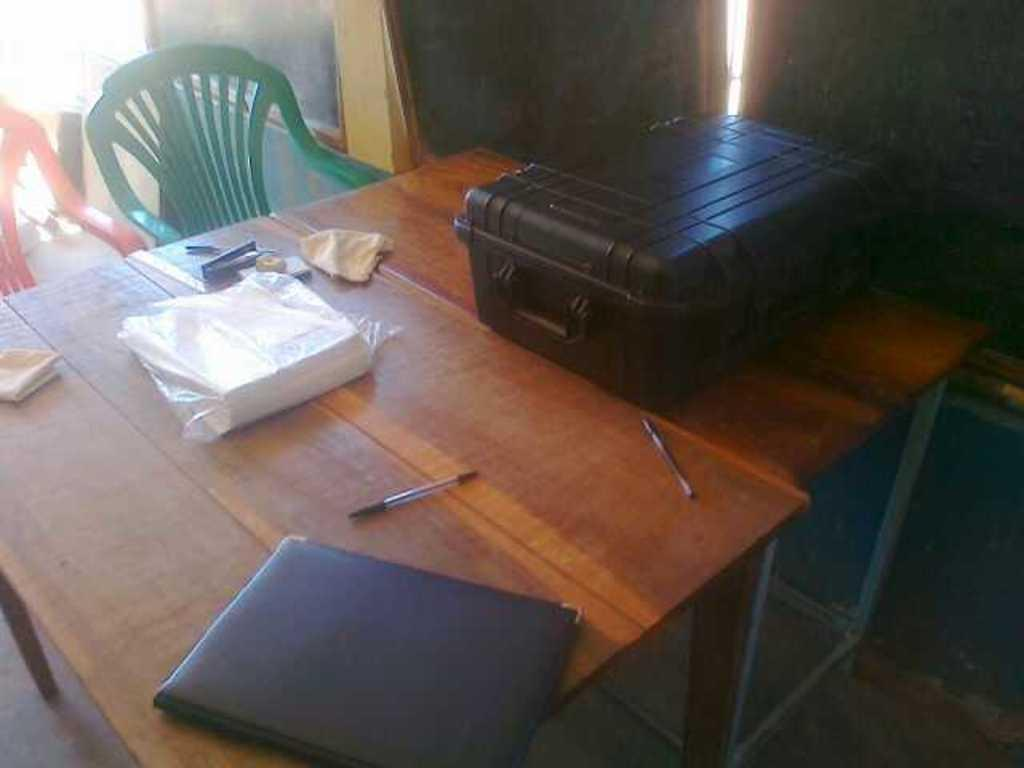What piece of furniture is present in the image? There is a table in the image. What object is placed on the table? There is a suitcase and a booklet on the table. What is the state of the booklet? The booklet is open. What other item can be seen on the table? There is a file on the table. What is likely to be used for sitting in the image? There is a chair in the image. Where is the waste pail located in the image? There is no waste pail present in the image. What type of store can be seen in the background of the image? There is no store visible in the image; it only features a table, suitcase, booklet, file, and chair. 